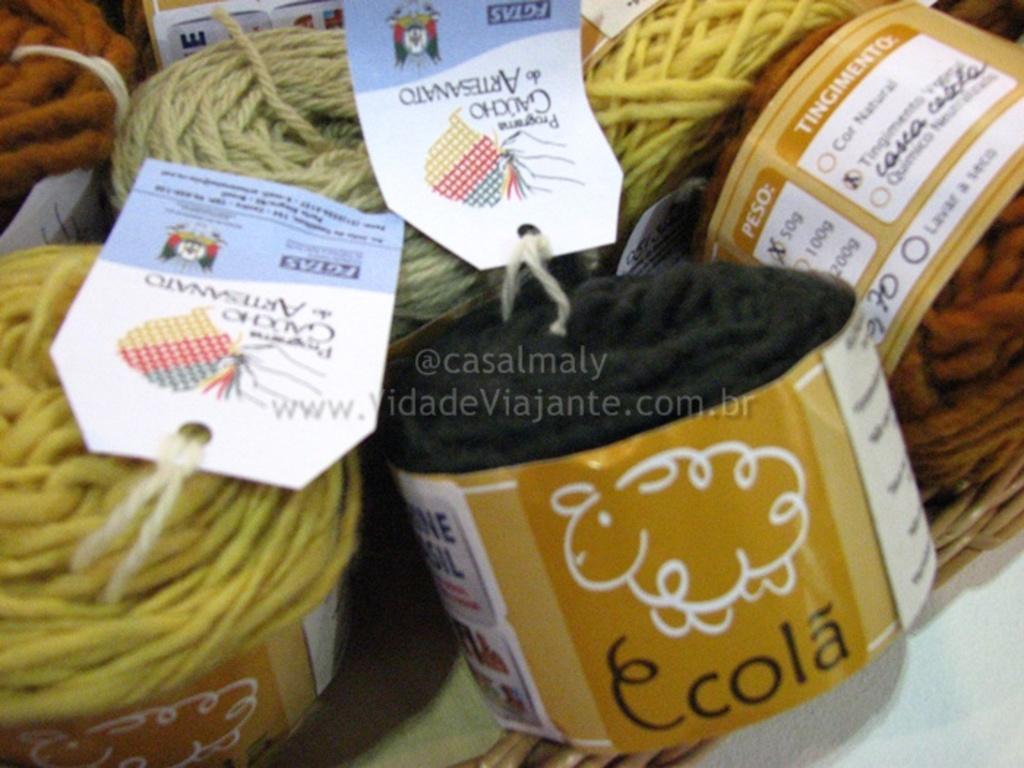Describe this image in one or two sentences. In this image we can see many yarns placed in the basket along with the tags. 